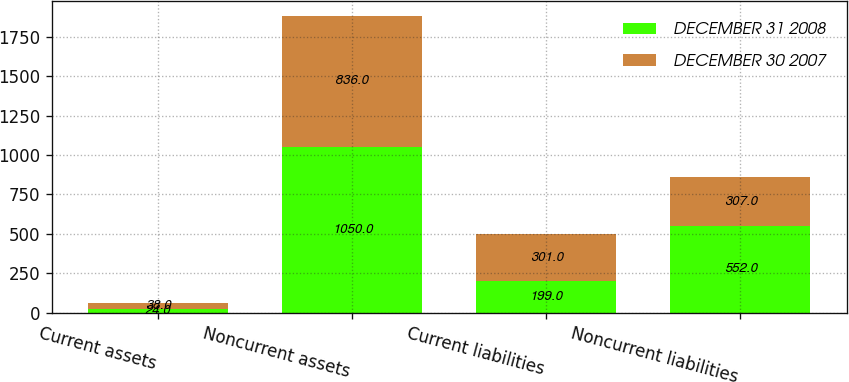<chart> <loc_0><loc_0><loc_500><loc_500><stacked_bar_chart><ecel><fcel>Current assets<fcel>Noncurrent assets<fcel>Current liabilities<fcel>Noncurrent liabilities<nl><fcel>DECEMBER 31 2008<fcel>24<fcel>1050<fcel>199<fcel>552<nl><fcel>DECEMBER 30 2007<fcel>38<fcel>836<fcel>301<fcel>307<nl></chart> 